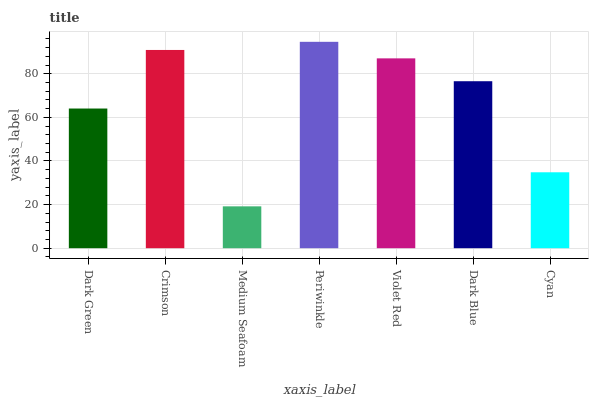Is Medium Seafoam the minimum?
Answer yes or no. Yes. Is Periwinkle the maximum?
Answer yes or no. Yes. Is Crimson the minimum?
Answer yes or no. No. Is Crimson the maximum?
Answer yes or no. No. Is Crimson greater than Dark Green?
Answer yes or no. Yes. Is Dark Green less than Crimson?
Answer yes or no. Yes. Is Dark Green greater than Crimson?
Answer yes or no. No. Is Crimson less than Dark Green?
Answer yes or no. No. Is Dark Blue the high median?
Answer yes or no. Yes. Is Dark Blue the low median?
Answer yes or no. Yes. Is Crimson the high median?
Answer yes or no. No. Is Dark Green the low median?
Answer yes or no. No. 